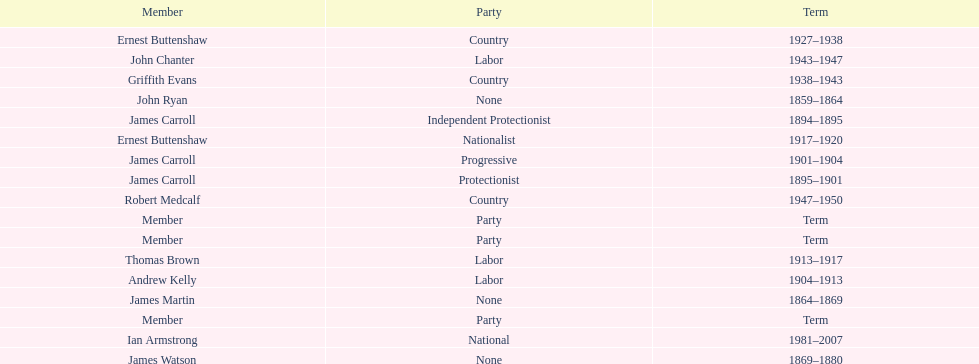Which member of the second incarnation of the lachlan was also a nationalist? Ernest Buttenshaw. Could you parse the entire table? {'header': ['Member', 'Party', 'Term'], 'rows': [['Ernest Buttenshaw', 'Country', '1927–1938'], ['John Chanter', 'Labor', '1943–1947'], ['Griffith Evans', 'Country', '1938–1943'], ['John Ryan', 'None', '1859–1864'], ['James Carroll', 'Independent Protectionist', '1894–1895'], ['Ernest Buttenshaw', 'Nationalist', '1917–1920'], ['James Carroll', 'Progressive', '1901–1904'], ['James Carroll', 'Protectionist', '1895–1901'], ['Robert Medcalf', 'Country', '1947–1950'], ['Member', 'Party', 'Term'], ['Member', 'Party', 'Term'], ['Thomas Brown', 'Labor', '1913–1917'], ['Andrew Kelly', 'Labor', '1904–1913'], ['James Martin', 'None', '1864–1869'], ['Member', 'Party', 'Term'], ['Ian Armstrong', 'National', '1981–2007'], ['James Watson', 'None', '1869–1880']]} 